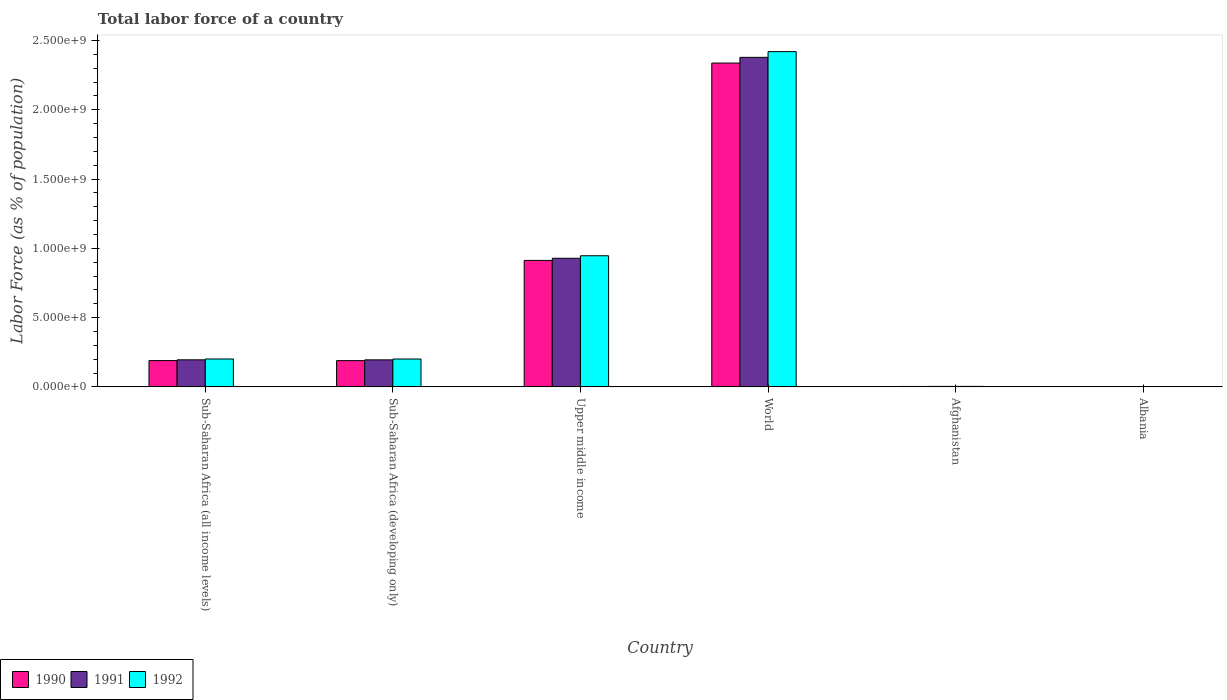How many different coloured bars are there?
Make the answer very short. 3. How many groups of bars are there?
Keep it short and to the point. 6. Are the number of bars on each tick of the X-axis equal?
Keep it short and to the point. Yes. How many bars are there on the 3rd tick from the left?
Your answer should be compact. 3. How many bars are there on the 5th tick from the right?
Offer a terse response. 3. What is the label of the 6th group of bars from the left?
Your answer should be compact. Albania. What is the percentage of labor force in 1992 in Afghanistan?
Your response must be concise. 3.50e+06. Across all countries, what is the maximum percentage of labor force in 1992?
Ensure brevity in your answer.  2.42e+09. Across all countries, what is the minimum percentage of labor force in 1990?
Your response must be concise. 1.42e+06. In which country was the percentage of labor force in 1992 minimum?
Provide a succinct answer. Albania. What is the total percentage of labor force in 1992 in the graph?
Provide a succinct answer. 3.77e+09. What is the difference between the percentage of labor force in 1991 in Albania and that in Upper middle income?
Offer a very short reply. -9.27e+08. What is the difference between the percentage of labor force in 1992 in Upper middle income and the percentage of labor force in 1991 in Albania?
Ensure brevity in your answer.  9.45e+08. What is the average percentage of labor force in 1991 per country?
Keep it short and to the point. 6.17e+08. What is the difference between the percentage of labor force of/in 1991 and percentage of labor force of/in 1990 in Upper middle income?
Provide a succinct answer. 1.55e+07. In how many countries, is the percentage of labor force in 1992 greater than 2400000000 %?
Keep it short and to the point. 1. What is the ratio of the percentage of labor force in 1991 in Afghanistan to that in Upper middle income?
Offer a terse response. 0. What is the difference between the highest and the second highest percentage of labor force in 1992?
Ensure brevity in your answer.  7.45e+08. What is the difference between the highest and the lowest percentage of labor force in 1992?
Offer a very short reply. 2.42e+09. What does the 3rd bar from the right in Sub-Saharan Africa (all income levels) represents?
Your response must be concise. 1990. Is it the case that in every country, the sum of the percentage of labor force in 1991 and percentage of labor force in 1990 is greater than the percentage of labor force in 1992?
Your answer should be very brief. Yes. How many bars are there?
Your answer should be compact. 18. Are all the bars in the graph horizontal?
Offer a very short reply. No. How many countries are there in the graph?
Keep it short and to the point. 6. What is the difference between two consecutive major ticks on the Y-axis?
Ensure brevity in your answer.  5.00e+08. Does the graph contain grids?
Your answer should be very brief. No. Where does the legend appear in the graph?
Offer a terse response. Bottom left. How many legend labels are there?
Give a very brief answer. 3. How are the legend labels stacked?
Your answer should be very brief. Horizontal. What is the title of the graph?
Offer a very short reply. Total labor force of a country. What is the label or title of the Y-axis?
Your response must be concise. Labor Force (as % of population). What is the Labor Force (as % of population) of 1990 in Sub-Saharan Africa (all income levels)?
Offer a terse response. 1.90e+08. What is the Labor Force (as % of population) of 1991 in Sub-Saharan Africa (all income levels)?
Offer a terse response. 1.95e+08. What is the Labor Force (as % of population) in 1992 in Sub-Saharan Africa (all income levels)?
Make the answer very short. 2.01e+08. What is the Labor Force (as % of population) of 1990 in Sub-Saharan Africa (developing only)?
Give a very brief answer. 1.90e+08. What is the Labor Force (as % of population) in 1991 in Sub-Saharan Africa (developing only)?
Keep it short and to the point. 1.95e+08. What is the Labor Force (as % of population) of 1992 in Sub-Saharan Africa (developing only)?
Make the answer very short. 2.01e+08. What is the Labor Force (as % of population) in 1990 in Upper middle income?
Your response must be concise. 9.13e+08. What is the Labor Force (as % of population) of 1991 in Upper middle income?
Keep it short and to the point. 9.28e+08. What is the Labor Force (as % of population) of 1992 in Upper middle income?
Keep it short and to the point. 9.46e+08. What is the Labor Force (as % of population) in 1990 in World?
Your response must be concise. 2.34e+09. What is the Labor Force (as % of population) in 1991 in World?
Ensure brevity in your answer.  2.38e+09. What is the Labor Force (as % of population) in 1992 in World?
Make the answer very short. 2.42e+09. What is the Labor Force (as % of population) of 1990 in Afghanistan?
Give a very brief answer. 3.08e+06. What is the Labor Force (as % of population) of 1991 in Afghanistan?
Your answer should be compact. 3.26e+06. What is the Labor Force (as % of population) in 1992 in Afghanistan?
Make the answer very short. 3.50e+06. What is the Labor Force (as % of population) of 1990 in Albania?
Your answer should be compact. 1.42e+06. What is the Labor Force (as % of population) of 1991 in Albania?
Make the answer very short. 1.43e+06. What is the Labor Force (as % of population) of 1992 in Albania?
Make the answer very short. 1.42e+06. Across all countries, what is the maximum Labor Force (as % of population) of 1990?
Provide a short and direct response. 2.34e+09. Across all countries, what is the maximum Labor Force (as % of population) in 1991?
Give a very brief answer. 2.38e+09. Across all countries, what is the maximum Labor Force (as % of population) of 1992?
Provide a short and direct response. 2.42e+09. Across all countries, what is the minimum Labor Force (as % of population) of 1990?
Ensure brevity in your answer.  1.42e+06. Across all countries, what is the minimum Labor Force (as % of population) of 1991?
Your response must be concise. 1.43e+06. Across all countries, what is the minimum Labor Force (as % of population) of 1992?
Your answer should be compact. 1.42e+06. What is the total Labor Force (as % of population) in 1990 in the graph?
Ensure brevity in your answer.  3.63e+09. What is the total Labor Force (as % of population) in 1991 in the graph?
Your answer should be very brief. 3.70e+09. What is the total Labor Force (as % of population) of 1992 in the graph?
Offer a very short reply. 3.77e+09. What is the difference between the Labor Force (as % of population) in 1990 in Sub-Saharan Africa (all income levels) and that in Sub-Saharan Africa (developing only)?
Provide a short and direct response. 2.02e+05. What is the difference between the Labor Force (as % of population) in 1991 in Sub-Saharan Africa (all income levels) and that in Sub-Saharan Africa (developing only)?
Provide a short and direct response. 2.06e+05. What is the difference between the Labor Force (as % of population) of 1992 in Sub-Saharan Africa (all income levels) and that in Sub-Saharan Africa (developing only)?
Provide a succinct answer. 2.11e+05. What is the difference between the Labor Force (as % of population) of 1990 in Sub-Saharan Africa (all income levels) and that in Upper middle income?
Make the answer very short. -7.23e+08. What is the difference between the Labor Force (as % of population) of 1991 in Sub-Saharan Africa (all income levels) and that in Upper middle income?
Make the answer very short. -7.33e+08. What is the difference between the Labor Force (as % of population) in 1992 in Sub-Saharan Africa (all income levels) and that in Upper middle income?
Make the answer very short. -7.45e+08. What is the difference between the Labor Force (as % of population) in 1990 in Sub-Saharan Africa (all income levels) and that in World?
Keep it short and to the point. -2.15e+09. What is the difference between the Labor Force (as % of population) of 1991 in Sub-Saharan Africa (all income levels) and that in World?
Ensure brevity in your answer.  -2.18e+09. What is the difference between the Labor Force (as % of population) of 1992 in Sub-Saharan Africa (all income levels) and that in World?
Ensure brevity in your answer.  -2.22e+09. What is the difference between the Labor Force (as % of population) in 1990 in Sub-Saharan Africa (all income levels) and that in Afghanistan?
Make the answer very short. 1.87e+08. What is the difference between the Labor Force (as % of population) of 1991 in Sub-Saharan Africa (all income levels) and that in Afghanistan?
Your answer should be compact. 1.92e+08. What is the difference between the Labor Force (as % of population) in 1992 in Sub-Saharan Africa (all income levels) and that in Afghanistan?
Your answer should be very brief. 1.98e+08. What is the difference between the Labor Force (as % of population) in 1990 in Sub-Saharan Africa (all income levels) and that in Albania?
Offer a very short reply. 1.88e+08. What is the difference between the Labor Force (as % of population) of 1991 in Sub-Saharan Africa (all income levels) and that in Albania?
Make the answer very short. 1.94e+08. What is the difference between the Labor Force (as % of population) in 1992 in Sub-Saharan Africa (all income levels) and that in Albania?
Offer a terse response. 2.00e+08. What is the difference between the Labor Force (as % of population) in 1990 in Sub-Saharan Africa (developing only) and that in Upper middle income?
Make the answer very short. -7.23e+08. What is the difference between the Labor Force (as % of population) of 1991 in Sub-Saharan Africa (developing only) and that in Upper middle income?
Provide a succinct answer. -7.33e+08. What is the difference between the Labor Force (as % of population) in 1992 in Sub-Saharan Africa (developing only) and that in Upper middle income?
Your response must be concise. -7.45e+08. What is the difference between the Labor Force (as % of population) in 1990 in Sub-Saharan Africa (developing only) and that in World?
Ensure brevity in your answer.  -2.15e+09. What is the difference between the Labor Force (as % of population) of 1991 in Sub-Saharan Africa (developing only) and that in World?
Your response must be concise. -2.18e+09. What is the difference between the Labor Force (as % of population) in 1992 in Sub-Saharan Africa (developing only) and that in World?
Give a very brief answer. -2.22e+09. What is the difference between the Labor Force (as % of population) of 1990 in Sub-Saharan Africa (developing only) and that in Afghanistan?
Provide a short and direct response. 1.86e+08. What is the difference between the Labor Force (as % of population) in 1991 in Sub-Saharan Africa (developing only) and that in Afghanistan?
Offer a terse response. 1.92e+08. What is the difference between the Labor Force (as % of population) of 1992 in Sub-Saharan Africa (developing only) and that in Afghanistan?
Make the answer very short. 1.98e+08. What is the difference between the Labor Force (as % of population) of 1990 in Sub-Saharan Africa (developing only) and that in Albania?
Your answer should be compact. 1.88e+08. What is the difference between the Labor Force (as % of population) in 1991 in Sub-Saharan Africa (developing only) and that in Albania?
Your answer should be very brief. 1.94e+08. What is the difference between the Labor Force (as % of population) in 1992 in Sub-Saharan Africa (developing only) and that in Albania?
Your response must be concise. 2.00e+08. What is the difference between the Labor Force (as % of population) of 1990 in Upper middle income and that in World?
Your response must be concise. -1.42e+09. What is the difference between the Labor Force (as % of population) in 1991 in Upper middle income and that in World?
Give a very brief answer. -1.45e+09. What is the difference between the Labor Force (as % of population) in 1992 in Upper middle income and that in World?
Your answer should be very brief. -1.47e+09. What is the difference between the Labor Force (as % of population) of 1990 in Upper middle income and that in Afghanistan?
Your response must be concise. 9.10e+08. What is the difference between the Labor Force (as % of population) in 1991 in Upper middle income and that in Afghanistan?
Provide a short and direct response. 9.25e+08. What is the difference between the Labor Force (as % of population) of 1992 in Upper middle income and that in Afghanistan?
Offer a very short reply. 9.43e+08. What is the difference between the Labor Force (as % of population) in 1990 in Upper middle income and that in Albania?
Provide a succinct answer. 9.12e+08. What is the difference between the Labor Force (as % of population) of 1991 in Upper middle income and that in Albania?
Ensure brevity in your answer.  9.27e+08. What is the difference between the Labor Force (as % of population) in 1992 in Upper middle income and that in Albania?
Give a very brief answer. 9.45e+08. What is the difference between the Labor Force (as % of population) in 1990 in World and that in Afghanistan?
Make the answer very short. 2.33e+09. What is the difference between the Labor Force (as % of population) of 1991 in World and that in Afghanistan?
Your answer should be compact. 2.38e+09. What is the difference between the Labor Force (as % of population) of 1992 in World and that in Afghanistan?
Keep it short and to the point. 2.42e+09. What is the difference between the Labor Force (as % of population) in 1990 in World and that in Albania?
Provide a succinct answer. 2.34e+09. What is the difference between the Labor Force (as % of population) of 1991 in World and that in Albania?
Your response must be concise. 2.38e+09. What is the difference between the Labor Force (as % of population) in 1992 in World and that in Albania?
Your response must be concise. 2.42e+09. What is the difference between the Labor Force (as % of population) in 1990 in Afghanistan and that in Albania?
Your response must be concise. 1.66e+06. What is the difference between the Labor Force (as % of population) of 1991 in Afghanistan and that in Albania?
Keep it short and to the point. 1.84e+06. What is the difference between the Labor Force (as % of population) in 1992 in Afghanistan and that in Albania?
Keep it short and to the point. 2.08e+06. What is the difference between the Labor Force (as % of population) in 1990 in Sub-Saharan Africa (all income levels) and the Labor Force (as % of population) in 1991 in Sub-Saharan Africa (developing only)?
Your answer should be very brief. -5.29e+06. What is the difference between the Labor Force (as % of population) in 1990 in Sub-Saharan Africa (all income levels) and the Labor Force (as % of population) in 1992 in Sub-Saharan Africa (developing only)?
Your response must be concise. -1.13e+07. What is the difference between the Labor Force (as % of population) in 1991 in Sub-Saharan Africa (all income levels) and the Labor Force (as % of population) in 1992 in Sub-Saharan Africa (developing only)?
Offer a very short reply. -5.81e+06. What is the difference between the Labor Force (as % of population) in 1990 in Sub-Saharan Africa (all income levels) and the Labor Force (as % of population) in 1991 in Upper middle income?
Your response must be concise. -7.39e+08. What is the difference between the Labor Force (as % of population) of 1990 in Sub-Saharan Africa (all income levels) and the Labor Force (as % of population) of 1992 in Upper middle income?
Your answer should be compact. -7.57e+08. What is the difference between the Labor Force (as % of population) of 1991 in Sub-Saharan Africa (all income levels) and the Labor Force (as % of population) of 1992 in Upper middle income?
Your response must be concise. -7.51e+08. What is the difference between the Labor Force (as % of population) of 1990 in Sub-Saharan Africa (all income levels) and the Labor Force (as % of population) of 1991 in World?
Ensure brevity in your answer.  -2.19e+09. What is the difference between the Labor Force (as % of population) in 1990 in Sub-Saharan Africa (all income levels) and the Labor Force (as % of population) in 1992 in World?
Your answer should be very brief. -2.23e+09. What is the difference between the Labor Force (as % of population) in 1991 in Sub-Saharan Africa (all income levels) and the Labor Force (as % of population) in 1992 in World?
Offer a very short reply. -2.22e+09. What is the difference between the Labor Force (as % of population) in 1990 in Sub-Saharan Africa (all income levels) and the Labor Force (as % of population) in 1991 in Afghanistan?
Make the answer very short. 1.87e+08. What is the difference between the Labor Force (as % of population) in 1990 in Sub-Saharan Africa (all income levels) and the Labor Force (as % of population) in 1992 in Afghanistan?
Your response must be concise. 1.86e+08. What is the difference between the Labor Force (as % of population) in 1991 in Sub-Saharan Africa (all income levels) and the Labor Force (as % of population) in 1992 in Afghanistan?
Your answer should be compact. 1.92e+08. What is the difference between the Labor Force (as % of population) in 1990 in Sub-Saharan Africa (all income levels) and the Labor Force (as % of population) in 1991 in Albania?
Your response must be concise. 1.88e+08. What is the difference between the Labor Force (as % of population) of 1990 in Sub-Saharan Africa (all income levels) and the Labor Force (as % of population) of 1992 in Albania?
Your answer should be very brief. 1.88e+08. What is the difference between the Labor Force (as % of population) of 1991 in Sub-Saharan Africa (all income levels) and the Labor Force (as % of population) of 1992 in Albania?
Your answer should be compact. 1.94e+08. What is the difference between the Labor Force (as % of population) in 1990 in Sub-Saharan Africa (developing only) and the Labor Force (as % of population) in 1991 in Upper middle income?
Make the answer very short. -7.39e+08. What is the difference between the Labor Force (as % of population) of 1990 in Sub-Saharan Africa (developing only) and the Labor Force (as % of population) of 1992 in Upper middle income?
Provide a succinct answer. -7.57e+08. What is the difference between the Labor Force (as % of population) of 1991 in Sub-Saharan Africa (developing only) and the Labor Force (as % of population) of 1992 in Upper middle income?
Ensure brevity in your answer.  -7.51e+08. What is the difference between the Labor Force (as % of population) of 1990 in Sub-Saharan Africa (developing only) and the Labor Force (as % of population) of 1991 in World?
Ensure brevity in your answer.  -2.19e+09. What is the difference between the Labor Force (as % of population) in 1990 in Sub-Saharan Africa (developing only) and the Labor Force (as % of population) in 1992 in World?
Provide a short and direct response. -2.23e+09. What is the difference between the Labor Force (as % of population) in 1991 in Sub-Saharan Africa (developing only) and the Labor Force (as % of population) in 1992 in World?
Offer a terse response. -2.23e+09. What is the difference between the Labor Force (as % of population) in 1990 in Sub-Saharan Africa (developing only) and the Labor Force (as % of population) in 1991 in Afghanistan?
Keep it short and to the point. 1.86e+08. What is the difference between the Labor Force (as % of population) in 1990 in Sub-Saharan Africa (developing only) and the Labor Force (as % of population) in 1992 in Afghanistan?
Keep it short and to the point. 1.86e+08. What is the difference between the Labor Force (as % of population) in 1991 in Sub-Saharan Africa (developing only) and the Labor Force (as % of population) in 1992 in Afghanistan?
Ensure brevity in your answer.  1.92e+08. What is the difference between the Labor Force (as % of population) in 1990 in Sub-Saharan Africa (developing only) and the Labor Force (as % of population) in 1991 in Albania?
Give a very brief answer. 1.88e+08. What is the difference between the Labor Force (as % of population) of 1990 in Sub-Saharan Africa (developing only) and the Labor Force (as % of population) of 1992 in Albania?
Keep it short and to the point. 1.88e+08. What is the difference between the Labor Force (as % of population) in 1991 in Sub-Saharan Africa (developing only) and the Labor Force (as % of population) in 1992 in Albania?
Your response must be concise. 1.94e+08. What is the difference between the Labor Force (as % of population) in 1990 in Upper middle income and the Labor Force (as % of population) in 1991 in World?
Keep it short and to the point. -1.47e+09. What is the difference between the Labor Force (as % of population) in 1990 in Upper middle income and the Labor Force (as % of population) in 1992 in World?
Provide a short and direct response. -1.51e+09. What is the difference between the Labor Force (as % of population) of 1991 in Upper middle income and the Labor Force (as % of population) of 1992 in World?
Ensure brevity in your answer.  -1.49e+09. What is the difference between the Labor Force (as % of population) in 1990 in Upper middle income and the Labor Force (as % of population) in 1991 in Afghanistan?
Offer a very short reply. 9.10e+08. What is the difference between the Labor Force (as % of population) in 1990 in Upper middle income and the Labor Force (as % of population) in 1992 in Afghanistan?
Ensure brevity in your answer.  9.09e+08. What is the difference between the Labor Force (as % of population) in 1991 in Upper middle income and the Labor Force (as % of population) in 1992 in Afghanistan?
Your answer should be compact. 9.25e+08. What is the difference between the Labor Force (as % of population) of 1990 in Upper middle income and the Labor Force (as % of population) of 1991 in Albania?
Give a very brief answer. 9.12e+08. What is the difference between the Labor Force (as % of population) in 1990 in Upper middle income and the Labor Force (as % of population) in 1992 in Albania?
Keep it short and to the point. 9.12e+08. What is the difference between the Labor Force (as % of population) of 1991 in Upper middle income and the Labor Force (as % of population) of 1992 in Albania?
Ensure brevity in your answer.  9.27e+08. What is the difference between the Labor Force (as % of population) in 1990 in World and the Labor Force (as % of population) in 1991 in Afghanistan?
Offer a very short reply. 2.33e+09. What is the difference between the Labor Force (as % of population) of 1990 in World and the Labor Force (as % of population) of 1992 in Afghanistan?
Your answer should be very brief. 2.33e+09. What is the difference between the Labor Force (as % of population) in 1991 in World and the Labor Force (as % of population) in 1992 in Afghanistan?
Your answer should be compact. 2.38e+09. What is the difference between the Labor Force (as % of population) of 1990 in World and the Labor Force (as % of population) of 1991 in Albania?
Offer a terse response. 2.34e+09. What is the difference between the Labor Force (as % of population) of 1990 in World and the Labor Force (as % of population) of 1992 in Albania?
Offer a terse response. 2.34e+09. What is the difference between the Labor Force (as % of population) in 1991 in World and the Labor Force (as % of population) in 1992 in Albania?
Make the answer very short. 2.38e+09. What is the difference between the Labor Force (as % of population) of 1990 in Afghanistan and the Labor Force (as % of population) of 1991 in Albania?
Provide a short and direct response. 1.66e+06. What is the difference between the Labor Force (as % of population) in 1990 in Afghanistan and the Labor Force (as % of population) in 1992 in Albania?
Give a very brief answer. 1.67e+06. What is the difference between the Labor Force (as % of population) in 1991 in Afghanistan and the Labor Force (as % of population) in 1992 in Albania?
Provide a succinct answer. 1.85e+06. What is the average Labor Force (as % of population) of 1990 per country?
Offer a very short reply. 6.06e+08. What is the average Labor Force (as % of population) in 1991 per country?
Provide a short and direct response. 6.17e+08. What is the average Labor Force (as % of population) of 1992 per country?
Provide a succinct answer. 6.29e+08. What is the difference between the Labor Force (as % of population) of 1990 and Labor Force (as % of population) of 1991 in Sub-Saharan Africa (all income levels)?
Your response must be concise. -5.49e+06. What is the difference between the Labor Force (as % of population) of 1990 and Labor Force (as % of population) of 1992 in Sub-Saharan Africa (all income levels)?
Make the answer very short. -1.15e+07. What is the difference between the Labor Force (as % of population) in 1991 and Labor Force (as % of population) in 1992 in Sub-Saharan Africa (all income levels)?
Ensure brevity in your answer.  -6.02e+06. What is the difference between the Labor Force (as % of population) in 1990 and Labor Force (as % of population) in 1991 in Sub-Saharan Africa (developing only)?
Offer a very short reply. -5.49e+06. What is the difference between the Labor Force (as % of population) in 1990 and Labor Force (as % of population) in 1992 in Sub-Saharan Africa (developing only)?
Ensure brevity in your answer.  -1.15e+07. What is the difference between the Labor Force (as % of population) of 1991 and Labor Force (as % of population) of 1992 in Sub-Saharan Africa (developing only)?
Provide a succinct answer. -6.01e+06. What is the difference between the Labor Force (as % of population) of 1990 and Labor Force (as % of population) of 1991 in Upper middle income?
Keep it short and to the point. -1.55e+07. What is the difference between the Labor Force (as % of population) of 1990 and Labor Force (as % of population) of 1992 in Upper middle income?
Provide a short and direct response. -3.35e+07. What is the difference between the Labor Force (as % of population) of 1991 and Labor Force (as % of population) of 1992 in Upper middle income?
Make the answer very short. -1.81e+07. What is the difference between the Labor Force (as % of population) of 1990 and Labor Force (as % of population) of 1991 in World?
Your answer should be very brief. -4.13e+07. What is the difference between the Labor Force (as % of population) of 1990 and Labor Force (as % of population) of 1992 in World?
Offer a terse response. -8.26e+07. What is the difference between the Labor Force (as % of population) of 1991 and Labor Force (as % of population) of 1992 in World?
Your answer should be very brief. -4.13e+07. What is the difference between the Labor Force (as % of population) in 1990 and Labor Force (as % of population) in 1991 in Afghanistan?
Make the answer very short. -1.80e+05. What is the difference between the Labor Force (as % of population) of 1990 and Labor Force (as % of population) of 1992 in Afghanistan?
Your answer should be compact. -4.13e+05. What is the difference between the Labor Force (as % of population) of 1991 and Labor Force (as % of population) of 1992 in Afghanistan?
Provide a succinct answer. -2.33e+05. What is the difference between the Labor Force (as % of population) of 1990 and Labor Force (as % of population) of 1991 in Albania?
Offer a terse response. -6581. What is the difference between the Labor Force (as % of population) in 1990 and Labor Force (as % of population) in 1992 in Albania?
Ensure brevity in your answer.  2941. What is the difference between the Labor Force (as % of population) in 1991 and Labor Force (as % of population) in 1992 in Albania?
Provide a short and direct response. 9522. What is the ratio of the Labor Force (as % of population) of 1990 in Sub-Saharan Africa (all income levels) to that in Upper middle income?
Provide a short and direct response. 0.21. What is the ratio of the Labor Force (as % of population) in 1991 in Sub-Saharan Africa (all income levels) to that in Upper middle income?
Keep it short and to the point. 0.21. What is the ratio of the Labor Force (as % of population) of 1992 in Sub-Saharan Africa (all income levels) to that in Upper middle income?
Provide a short and direct response. 0.21. What is the ratio of the Labor Force (as % of population) in 1990 in Sub-Saharan Africa (all income levels) to that in World?
Keep it short and to the point. 0.08. What is the ratio of the Labor Force (as % of population) in 1991 in Sub-Saharan Africa (all income levels) to that in World?
Keep it short and to the point. 0.08. What is the ratio of the Labor Force (as % of population) of 1992 in Sub-Saharan Africa (all income levels) to that in World?
Give a very brief answer. 0.08. What is the ratio of the Labor Force (as % of population) of 1990 in Sub-Saharan Africa (all income levels) to that in Afghanistan?
Give a very brief answer. 61.55. What is the ratio of the Labor Force (as % of population) in 1991 in Sub-Saharan Africa (all income levels) to that in Afghanistan?
Give a very brief answer. 59.83. What is the ratio of the Labor Force (as % of population) of 1992 in Sub-Saharan Africa (all income levels) to that in Afghanistan?
Make the answer very short. 57.57. What is the ratio of the Labor Force (as % of population) in 1990 in Sub-Saharan Africa (all income levels) to that in Albania?
Keep it short and to the point. 133.64. What is the ratio of the Labor Force (as % of population) of 1991 in Sub-Saharan Africa (all income levels) to that in Albania?
Keep it short and to the point. 136.87. What is the ratio of the Labor Force (as % of population) of 1992 in Sub-Saharan Africa (all income levels) to that in Albania?
Your answer should be compact. 142.04. What is the ratio of the Labor Force (as % of population) of 1990 in Sub-Saharan Africa (developing only) to that in Upper middle income?
Provide a succinct answer. 0.21. What is the ratio of the Labor Force (as % of population) in 1991 in Sub-Saharan Africa (developing only) to that in Upper middle income?
Offer a very short reply. 0.21. What is the ratio of the Labor Force (as % of population) in 1992 in Sub-Saharan Africa (developing only) to that in Upper middle income?
Give a very brief answer. 0.21. What is the ratio of the Labor Force (as % of population) in 1990 in Sub-Saharan Africa (developing only) to that in World?
Your answer should be compact. 0.08. What is the ratio of the Labor Force (as % of population) in 1991 in Sub-Saharan Africa (developing only) to that in World?
Keep it short and to the point. 0.08. What is the ratio of the Labor Force (as % of population) of 1992 in Sub-Saharan Africa (developing only) to that in World?
Make the answer very short. 0.08. What is the ratio of the Labor Force (as % of population) in 1990 in Sub-Saharan Africa (developing only) to that in Afghanistan?
Ensure brevity in your answer.  61.48. What is the ratio of the Labor Force (as % of population) of 1991 in Sub-Saharan Africa (developing only) to that in Afghanistan?
Provide a short and direct response. 59.77. What is the ratio of the Labor Force (as % of population) in 1992 in Sub-Saharan Africa (developing only) to that in Afghanistan?
Offer a very short reply. 57.51. What is the ratio of the Labor Force (as % of population) of 1990 in Sub-Saharan Africa (developing only) to that in Albania?
Provide a short and direct response. 133.5. What is the ratio of the Labor Force (as % of population) in 1991 in Sub-Saharan Africa (developing only) to that in Albania?
Offer a terse response. 136.73. What is the ratio of the Labor Force (as % of population) of 1992 in Sub-Saharan Africa (developing only) to that in Albania?
Ensure brevity in your answer.  141.89. What is the ratio of the Labor Force (as % of population) in 1990 in Upper middle income to that in World?
Offer a terse response. 0.39. What is the ratio of the Labor Force (as % of population) of 1991 in Upper middle income to that in World?
Offer a terse response. 0.39. What is the ratio of the Labor Force (as % of population) of 1992 in Upper middle income to that in World?
Your response must be concise. 0.39. What is the ratio of the Labor Force (as % of population) of 1990 in Upper middle income to that in Afghanistan?
Ensure brevity in your answer.  296.08. What is the ratio of the Labor Force (as % of population) of 1991 in Upper middle income to that in Afghanistan?
Give a very brief answer. 284.49. What is the ratio of the Labor Force (as % of population) in 1992 in Upper middle income to that in Afghanistan?
Provide a succinct answer. 270.69. What is the ratio of the Labor Force (as % of population) in 1990 in Upper middle income to that in Albania?
Your response must be concise. 642.88. What is the ratio of the Labor Force (as % of population) in 1991 in Upper middle income to that in Albania?
Make the answer very short. 650.78. What is the ratio of the Labor Force (as % of population) in 1992 in Upper middle income to that in Albania?
Your response must be concise. 667.89. What is the ratio of the Labor Force (as % of population) of 1990 in World to that in Afghanistan?
Your answer should be very brief. 758.09. What is the ratio of the Labor Force (as % of population) in 1991 in World to that in Afghanistan?
Your response must be concise. 728.92. What is the ratio of the Labor Force (as % of population) of 1992 in World to that in Afghanistan?
Provide a succinct answer. 692.14. What is the ratio of the Labor Force (as % of population) in 1990 in World to that in Albania?
Keep it short and to the point. 1646.06. What is the ratio of the Labor Force (as % of population) of 1991 in World to that in Albania?
Offer a very short reply. 1667.42. What is the ratio of the Labor Force (as % of population) in 1992 in World to that in Albania?
Your response must be concise. 1707.73. What is the ratio of the Labor Force (as % of population) of 1990 in Afghanistan to that in Albania?
Keep it short and to the point. 2.17. What is the ratio of the Labor Force (as % of population) of 1991 in Afghanistan to that in Albania?
Provide a succinct answer. 2.29. What is the ratio of the Labor Force (as % of population) in 1992 in Afghanistan to that in Albania?
Give a very brief answer. 2.47. What is the difference between the highest and the second highest Labor Force (as % of population) in 1990?
Your answer should be very brief. 1.42e+09. What is the difference between the highest and the second highest Labor Force (as % of population) in 1991?
Give a very brief answer. 1.45e+09. What is the difference between the highest and the second highest Labor Force (as % of population) of 1992?
Your answer should be very brief. 1.47e+09. What is the difference between the highest and the lowest Labor Force (as % of population) in 1990?
Keep it short and to the point. 2.34e+09. What is the difference between the highest and the lowest Labor Force (as % of population) in 1991?
Provide a short and direct response. 2.38e+09. What is the difference between the highest and the lowest Labor Force (as % of population) in 1992?
Provide a succinct answer. 2.42e+09. 